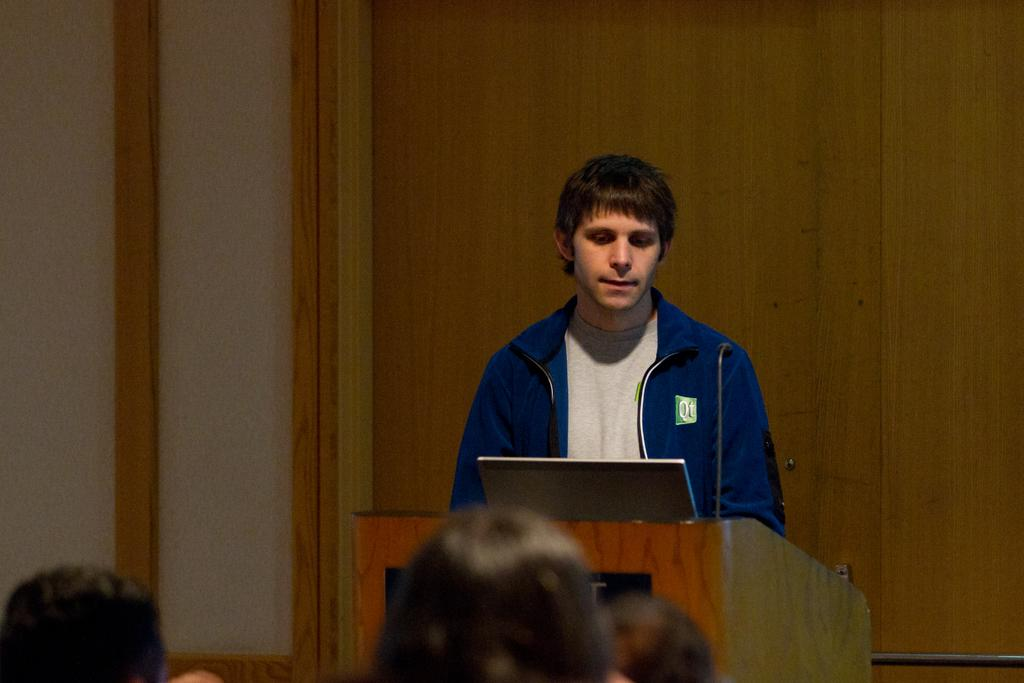How many people are in the image? There are people in the image, but the exact number is not specified. What is the man in the image doing? The man is standing in front of a podium. What can be found on the podium? There are microphones and a laptop on the podium. What is visible in the background of the image? There is a wooden wall in the background of the image. How many sheep are visible in the image? There are no sheep present in the image. What size is the laptop on the podium? The size of the laptop is not mentioned in the facts, so it cannot be determined from the image. 